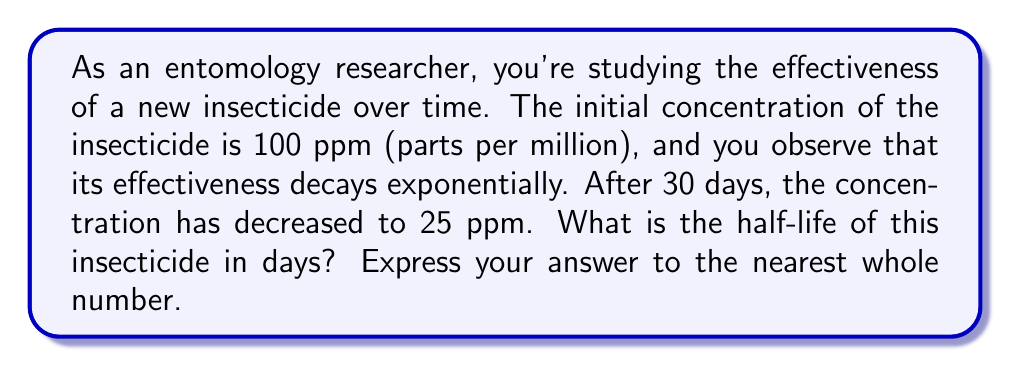Could you help me with this problem? Let's approach this step-by-step using the exponential decay formula:

1) The general form of exponential decay is:
   $$ A(t) = A_0 \cdot e^{-kt} $$
   Where $A(t)$ is the amount at time $t$, $A_0$ is the initial amount, $k$ is the decay constant, and $t$ is time.

2) We know:
   - $A_0 = 100$ ppm (initial concentration)
   - $A(30) = 25$ ppm (concentration after 30 days)
   - $t = 30$ days

3) Substituting these values into the formula:
   $$ 25 = 100 \cdot e^{-30k} $$

4) Dividing both sides by 100:
   $$ 0.25 = e^{-30k} $$

5) Taking natural log of both sides:
   $$ \ln(0.25) = -30k $$

6) Solving for $k$:
   $$ k = -\frac{\ln(0.25)}{30} \approx 0.0462 $$

7) Now, to find the half-life $(t_{1/2})$, we use the formula:
   $$ t_{1/2} = \frac{\ln(2)}{k} $$

8) Substituting our value for $k$:
   $$ t_{1/2} = \frac{\ln(2)}{0.0462} \approx 15.01 \text{ days} $$

9) Rounding to the nearest whole number:
   $$ t_{1/2} \approx 15 \text{ days} $$
Answer: 15 days 